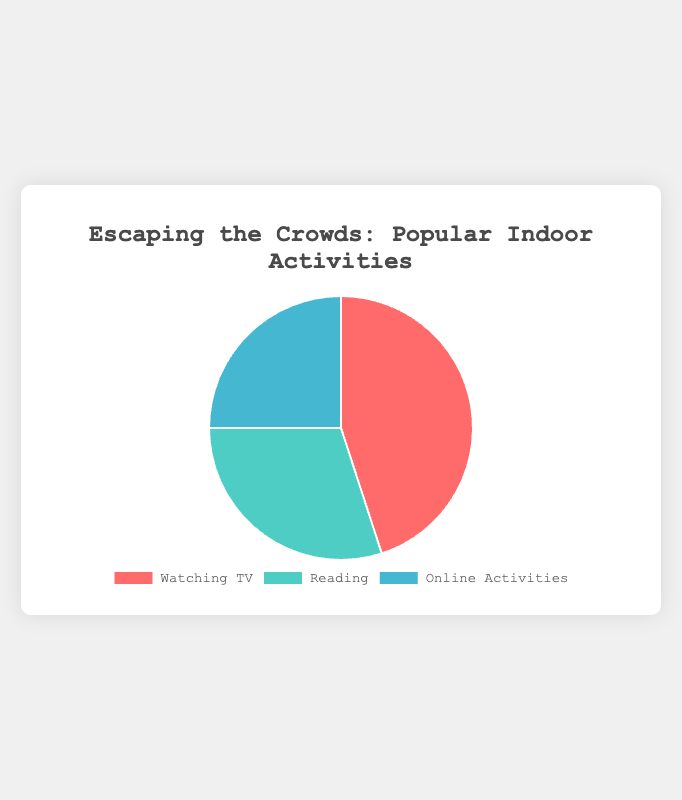Which activity is the most popular for staying indoors during major events? By looking at the chart, the segment with the largest size represents the most popular activity. The "Watching TV" segment is the largest.
Answer: Watching TV What percentage of people engage in online activities when staying indoors? The chart displays the percentage for each activity. The "Online Activities" segment shows 25%.
Answer: 25% How much larger is the percentage of people watching TV compared to those engaged in online activities? The percentage for "Watching TV" is 45%, and for "Online Activities" is 25%. The difference is 45% - 25% = 20%.
Answer: 20% Which two activities together make up more than half of the preferences? To determine this, add the percentages of each pair of activities. "Watching TV" (45%) + "Reading" (30%) = 75%, "Watching TV" (45%) + "Online Activities" (25%) = 70%, "Reading" (30%) + "Online Activities" (25%) = 55%. Each of these pairs exceeds 50%.
Answer: Watching TV and Reading, Watching TV and Online Activities, Reading and Online Activities Which activity is the smallest segment on the pie chart? The smallest segment will have the smallest percentage value. The "Online Activities" segment has 25%, which is the smallest.
Answer: Online Activities What is the combined percentage of people who prefer reading or online activities? Add the percentage for "Reading" (30%) and "Online Activities" (25%): 30% + 25% = 55%.
Answer: 55% Is the percentage of people reading higher or lower than those engaged in online activities? Compare the percentages shown on the chart: "Reading" is 30% and "Online Activities" is 25%. 30% is higher than 25%.
Answer: Higher If we equally divided the chart into four sections, what would be the target percentage for each segment, and how does each actual segment compare to this ideal division? Ideally, each section would represent 100%/4 = 25%. Compare this with actual percentages: "Watching TV" (45%) is higher, "Reading" (30%) is higher, "Online Activities" (25%) is equal.
Answer: 25% ideal; Watching TV is higher, Reading is higher, Online Activities is equal 